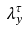<formula> <loc_0><loc_0><loc_500><loc_500>\lambda _ { y } ^ { \tau }</formula> 